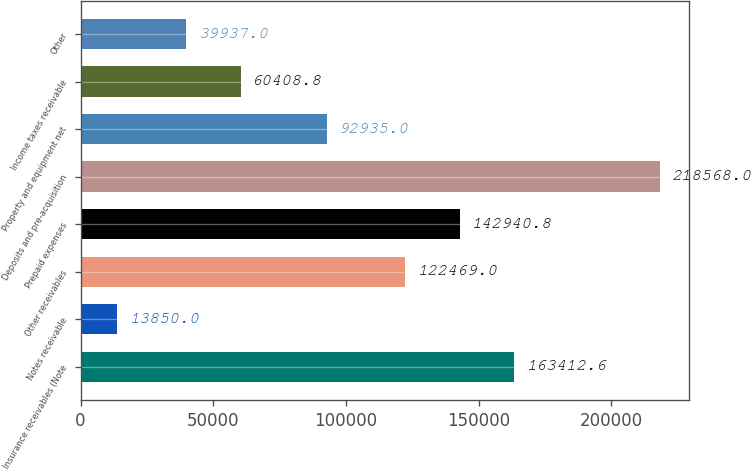Convert chart to OTSL. <chart><loc_0><loc_0><loc_500><loc_500><bar_chart><fcel>Insurance receivables (Note<fcel>Notes receivable<fcel>Other receivables<fcel>Prepaid expenses<fcel>Deposits and pre-acquisition<fcel>Property and equipment net<fcel>Income taxes receivable<fcel>Other<nl><fcel>163413<fcel>13850<fcel>122469<fcel>142941<fcel>218568<fcel>92935<fcel>60408.8<fcel>39937<nl></chart> 